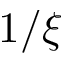<formula> <loc_0><loc_0><loc_500><loc_500>1 / \xi</formula> 